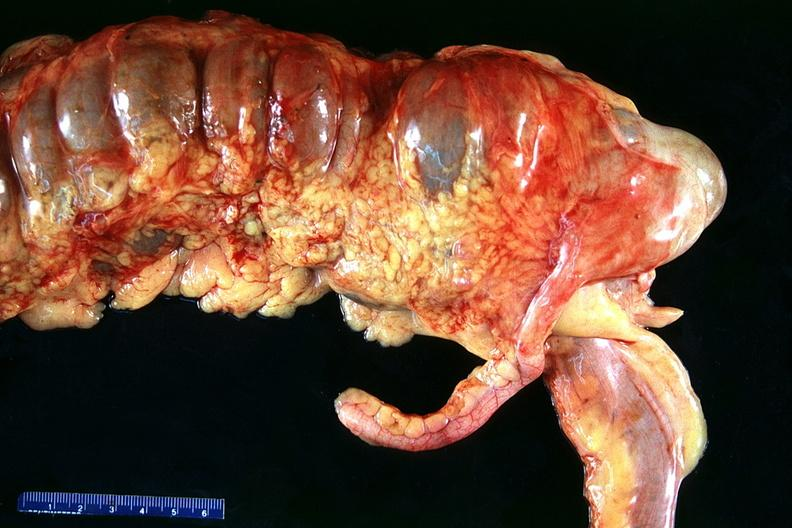s placenta present?
Answer the question using a single word or phrase. No 